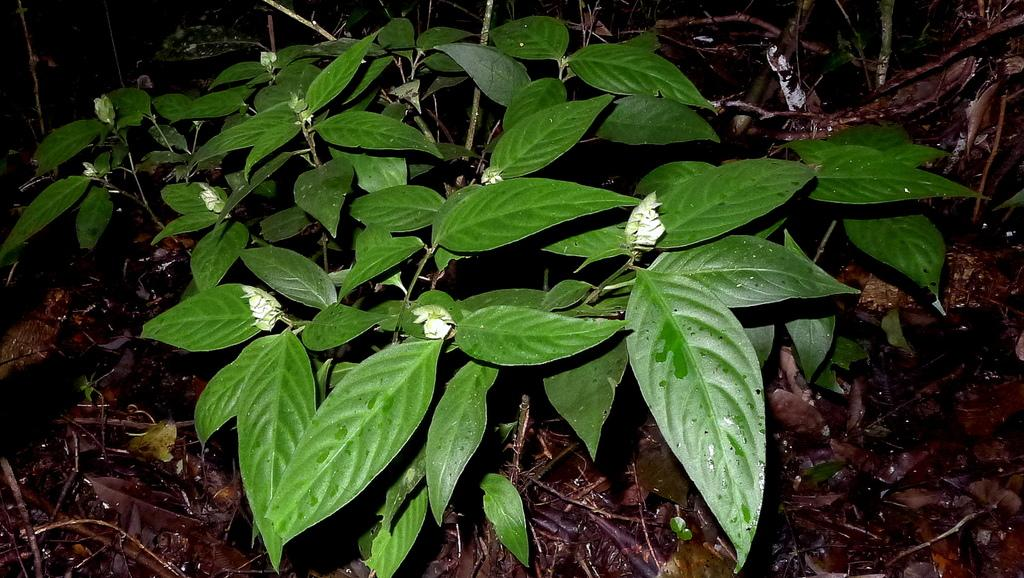What type of living organisms can be seen in the image? Plants can be seen in the image. What is present on the ground in the image? There are dry leaves on the ground in the image. What type of advertisement can be seen on the heart in the image? There is no advertisement or heart present in the image; it only features plants and dry leaves on the ground. 